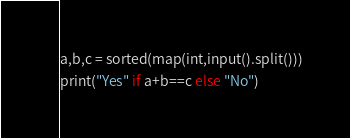Convert code to text. <code><loc_0><loc_0><loc_500><loc_500><_Python_>a,b,c = sorted(map(int,input().split()))
print("Yes" if a+b==c else "No")</code> 